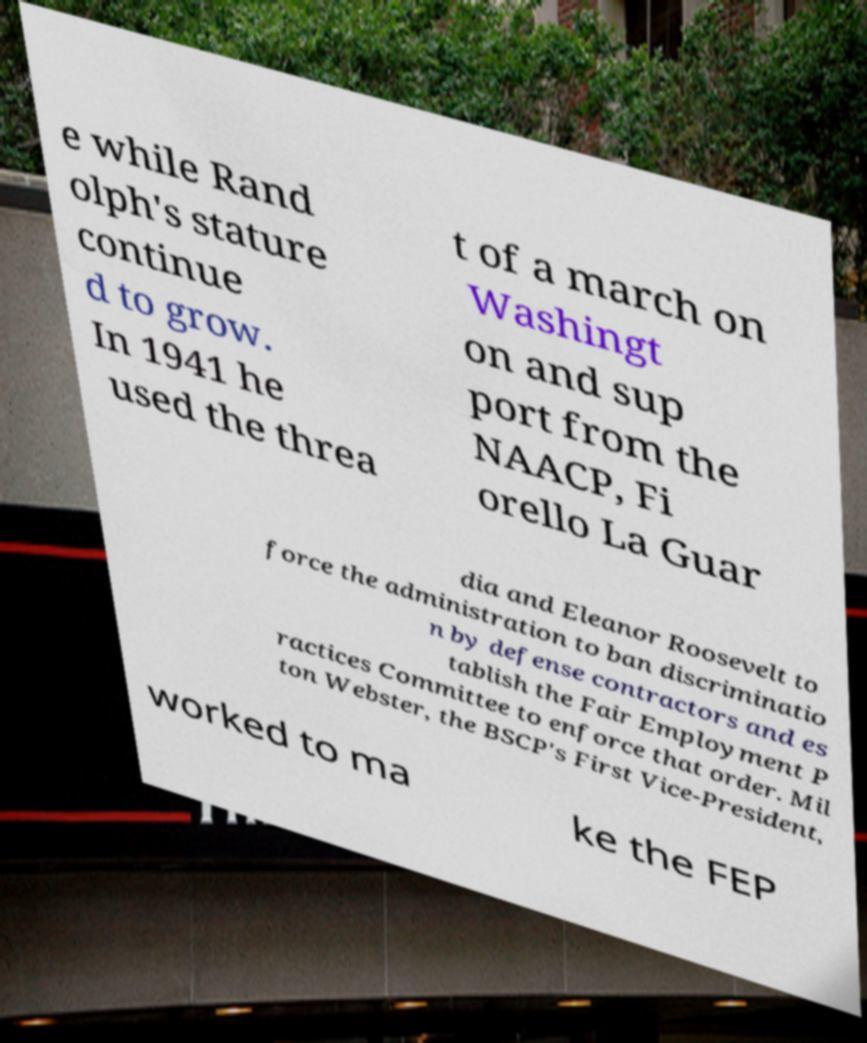Please read and relay the text visible in this image. What does it say? e while Rand olph's stature continue d to grow. In 1941 he used the threa t of a march on Washingt on and sup port from the NAACP, Fi orello La Guar dia and Eleanor Roosevelt to force the administration to ban discriminatio n by defense contractors and es tablish the Fair Employment P ractices Committee to enforce that order. Mil ton Webster, the BSCP's First Vice-President, worked to ma ke the FEP 